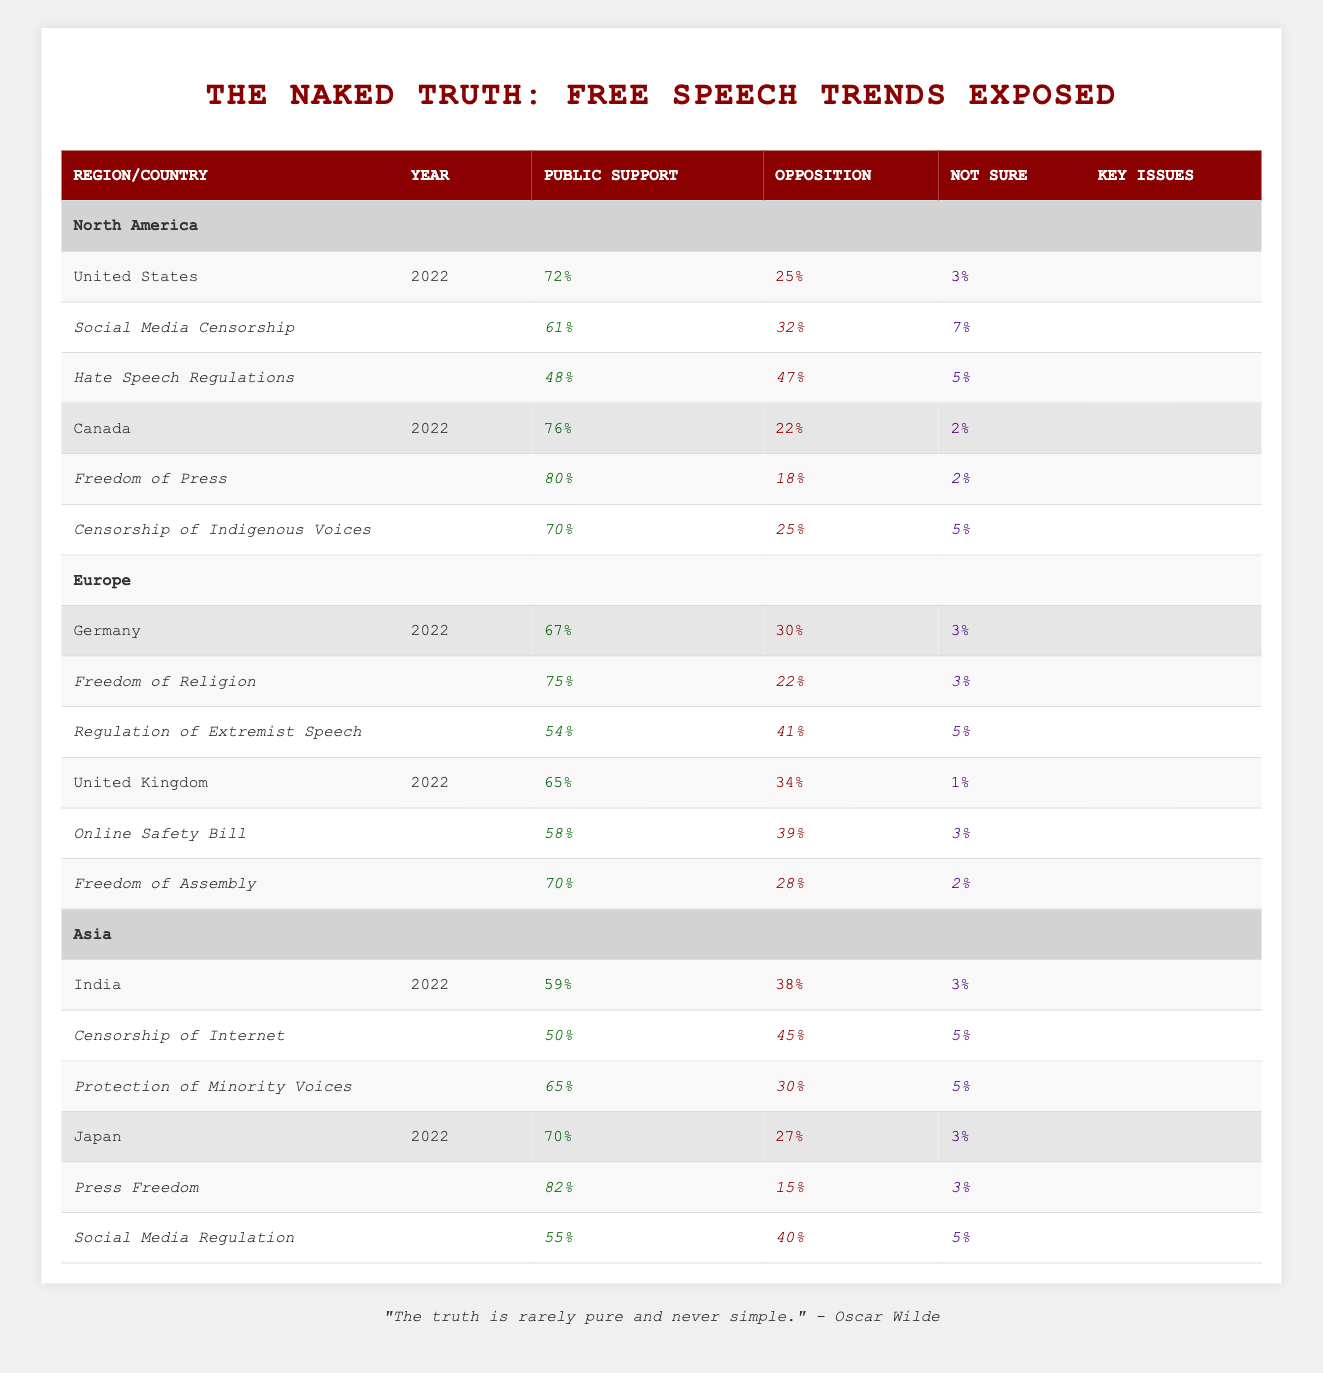What percentage of the public supports free speech in Canada? According to the table, in Canada, the Public Support for free speech is listed as 76%.
Answer: 76% Which country shows the highest support for Freedom of Press? The table indicates that among the key issues, Japan has the highest support for Press Freedom at 82%.
Answer: 82% Is there a significant difference in Public Support for free speech between the United States and Germany? In the United States, Public Support is 72%, while in Germany, it is 67%. The difference is 5%.
Answer: Yes How does the opposition to Hate Speech Regulations in the United States compare with the support in Germany for Regulation of Extremist Speech? In the United States, 47% oppose Hate Speech Regulations, and in Germany, 41% oppose Regulation of Extremist Speech. The US has a higher opposition by 6%.
Answer: 6% What is the combined percentage of Not Sure responses in India and Japan regarding issues of free speech? In India, the Not Sure response is 3%, and in Japan, it is also 3%. The combined percentage is 3% + 3% = 6%.
Answer: 6% Among all countries listed, which has the lowest percentage of Public Support for free speech? Looking through the table, India has the lowest Public Support at 59%.
Answer: 59% 